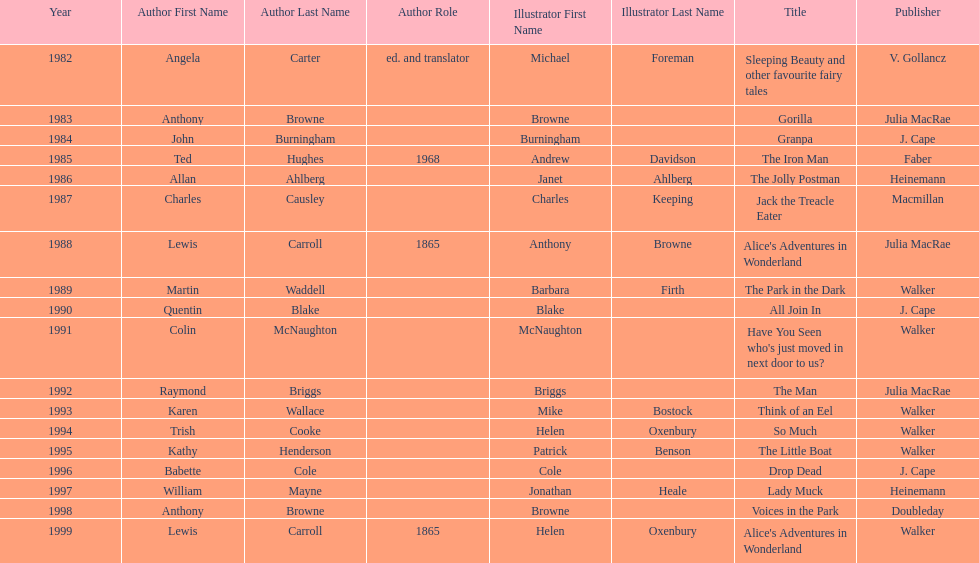Which author wrote the first award winner? Angela Carter. 